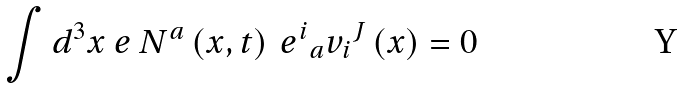<formula> <loc_0><loc_0><loc_500><loc_500>\int d ^ { 3 } x \ e \ N ^ { a } \left ( x , t \right ) \ { e ^ { i } } _ { a } { v _ { i } } ^ { J } \left ( x \right ) = 0</formula> 